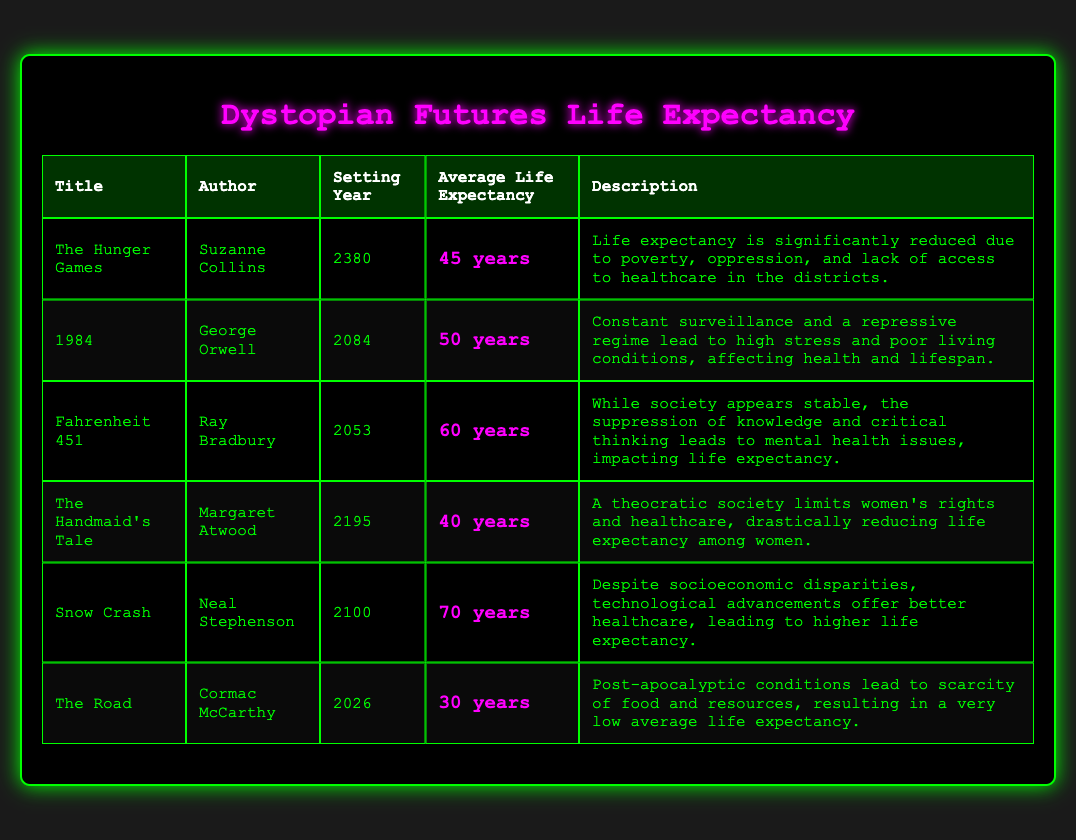What is the average life expectancy in "The Hunger Games"? The table lists "The Hunger Games" with an average life expectancy of 45 years, which can be found directly in the "Average Life Expectancy" column for that title.
Answer: 45 years What is the setting year for "1984"? Looking at the table, the "setting year" column shows that "1984" is set in the year 2084.
Answer: 2084 Which title has the lowest average life expectancy? Checking the average life expectancy values, "The Road" has the lowest at 30 years compared to the other titles.
Answer: The Road Is the average life expectancy in "Fahrenheit 451" greater than 50 years? The average life expectancy for "Fahrenheit 451" is listed as 60 years, which is greater than 50 years. Thus, the answer is yes.
Answer: Yes What is the difference in average life expectancy between "The Handmaid's Tale" and "Snow Crash"? "The Handmaid's Tale" has an average life expectancy of 40 years, while "Snow Crash" has 70 years. The difference is 70 - 40 = 30 years.
Answer: 30 years How many titles have an average life expectancy below 50 years? From the table, the titles with life expectancy below 50 years are "The Hunger Games" (45), "The Handmaid's Tale" (40), and "The Road" (30). This sums up to 3 titles.
Answer: 3 titles What is the average life expectancy of the listed dystopian futures? To find the average, sum the average life expectancies: (45 + 50 + 60 + 40 + 70 + 30) = 295, and then divide by 6 (the number of titles), giving 295/6 ≈ 49.17 years.
Answer: 49.17 years Which author wrote a book with an average life expectancy higher than 60 years? Looking through the table, only "Snow Crash" by Neal Stephenson has an average life expectancy of 70 years, which is higher than 60 years.
Answer: Neal Stephenson In which year is "The Road" set? The setting year for "The Road" is listed as 2026 in the table.
Answer: 2026 